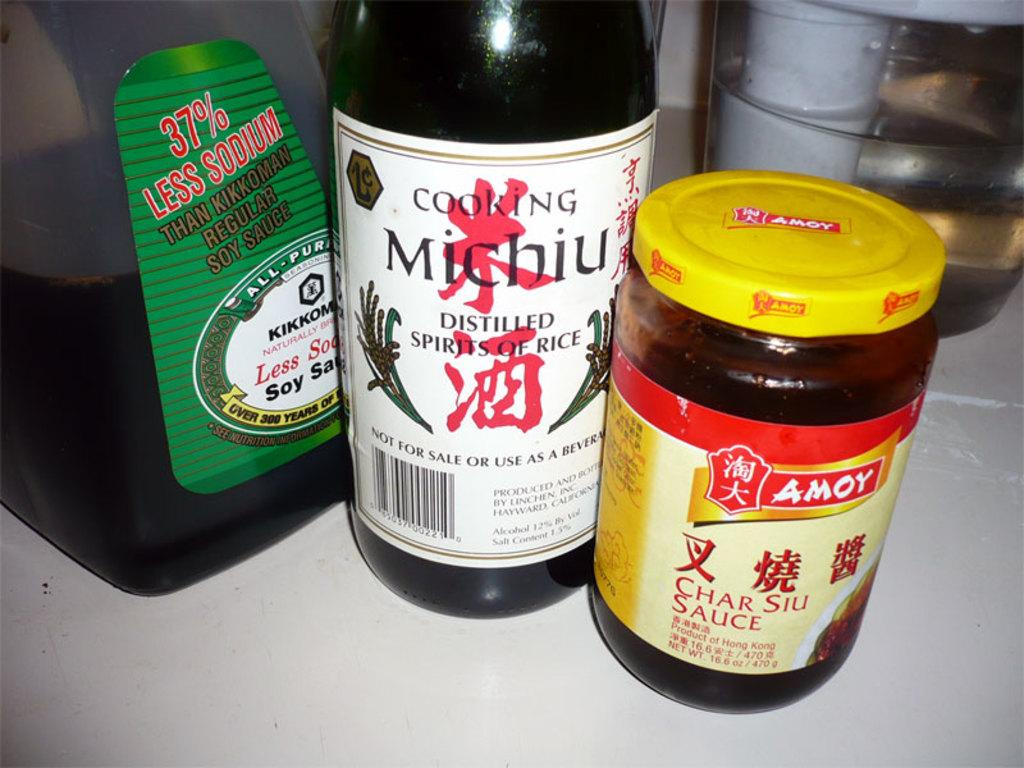<image>
Present a compact description of the photo's key features. Cooking Michiu distilled spirits of rice next to a bottle of Char Siu Sauce. 